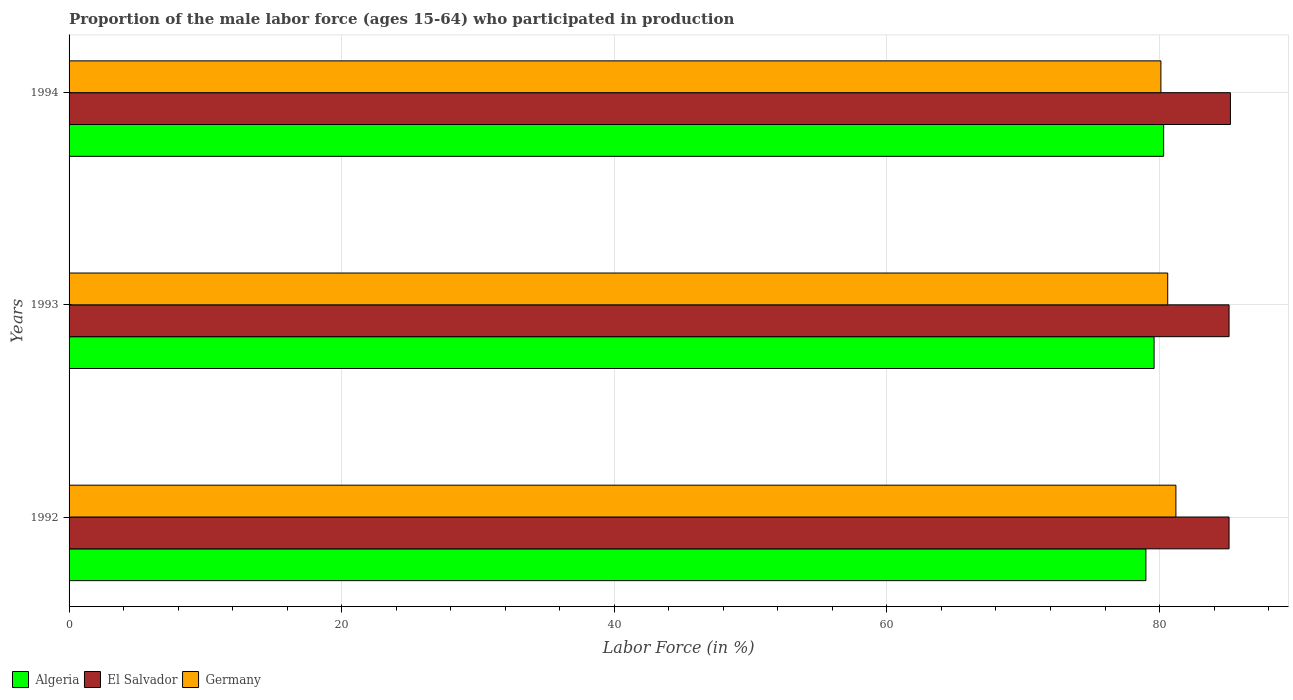How many different coloured bars are there?
Keep it short and to the point. 3. How many groups of bars are there?
Give a very brief answer. 3. Are the number of bars per tick equal to the number of legend labels?
Give a very brief answer. Yes. Are the number of bars on each tick of the Y-axis equal?
Provide a short and direct response. Yes. How many bars are there on the 3rd tick from the top?
Make the answer very short. 3. How many bars are there on the 3rd tick from the bottom?
Your answer should be compact. 3. In how many cases, is the number of bars for a given year not equal to the number of legend labels?
Your response must be concise. 0. What is the proportion of the male labor force who participated in production in El Salvador in 1994?
Your response must be concise. 85.2. Across all years, what is the maximum proportion of the male labor force who participated in production in Algeria?
Offer a terse response. 80.3. Across all years, what is the minimum proportion of the male labor force who participated in production in Algeria?
Keep it short and to the point. 79. What is the total proportion of the male labor force who participated in production in Algeria in the graph?
Your answer should be very brief. 238.9. What is the difference between the proportion of the male labor force who participated in production in Algeria in 1992 and that in 1994?
Ensure brevity in your answer.  -1.3. What is the difference between the proportion of the male labor force who participated in production in El Salvador in 1992 and the proportion of the male labor force who participated in production in Algeria in 1994?
Provide a short and direct response. 4.8. What is the average proportion of the male labor force who participated in production in Germany per year?
Keep it short and to the point. 80.63. In the year 1994, what is the difference between the proportion of the male labor force who participated in production in Algeria and proportion of the male labor force who participated in production in El Salvador?
Offer a terse response. -4.9. What is the ratio of the proportion of the male labor force who participated in production in Algeria in 1993 to that in 1994?
Offer a very short reply. 0.99. Is the proportion of the male labor force who participated in production in Germany in 1992 less than that in 1994?
Keep it short and to the point. No. Is the difference between the proportion of the male labor force who participated in production in Algeria in 1992 and 1993 greater than the difference between the proportion of the male labor force who participated in production in El Salvador in 1992 and 1993?
Give a very brief answer. No. What is the difference between the highest and the second highest proportion of the male labor force who participated in production in Algeria?
Offer a very short reply. 0.7. What is the difference between the highest and the lowest proportion of the male labor force who participated in production in Germany?
Ensure brevity in your answer.  1.1. In how many years, is the proportion of the male labor force who participated in production in Algeria greater than the average proportion of the male labor force who participated in production in Algeria taken over all years?
Offer a very short reply. 1. Is the sum of the proportion of the male labor force who participated in production in Algeria in 1992 and 1994 greater than the maximum proportion of the male labor force who participated in production in El Salvador across all years?
Keep it short and to the point. Yes. What does the 1st bar from the top in 1993 represents?
Your answer should be very brief. Germany. What does the 1st bar from the bottom in 1993 represents?
Make the answer very short. Algeria. Is it the case that in every year, the sum of the proportion of the male labor force who participated in production in Germany and proportion of the male labor force who participated in production in El Salvador is greater than the proportion of the male labor force who participated in production in Algeria?
Offer a terse response. Yes. How many bars are there?
Provide a succinct answer. 9. What is the difference between two consecutive major ticks on the X-axis?
Provide a succinct answer. 20. Are the values on the major ticks of X-axis written in scientific E-notation?
Your response must be concise. No. Does the graph contain any zero values?
Give a very brief answer. No. Does the graph contain grids?
Offer a very short reply. Yes. Where does the legend appear in the graph?
Your answer should be compact. Bottom left. How many legend labels are there?
Give a very brief answer. 3. What is the title of the graph?
Provide a succinct answer. Proportion of the male labor force (ages 15-64) who participated in production. Does "Hungary" appear as one of the legend labels in the graph?
Provide a succinct answer. No. What is the Labor Force (in %) in Algeria in 1992?
Provide a short and direct response. 79. What is the Labor Force (in %) of El Salvador in 1992?
Provide a short and direct response. 85.1. What is the Labor Force (in %) of Germany in 1992?
Your answer should be compact. 81.2. What is the Labor Force (in %) of Algeria in 1993?
Give a very brief answer. 79.6. What is the Labor Force (in %) in El Salvador in 1993?
Keep it short and to the point. 85.1. What is the Labor Force (in %) in Germany in 1993?
Provide a short and direct response. 80.6. What is the Labor Force (in %) in Algeria in 1994?
Give a very brief answer. 80.3. What is the Labor Force (in %) of El Salvador in 1994?
Offer a very short reply. 85.2. What is the Labor Force (in %) in Germany in 1994?
Your answer should be very brief. 80.1. Across all years, what is the maximum Labor Force (in %) in Algeria?
Provide a succinct answer. 80.3. Across all years, what is the maximum Labor Force (in %) of El Salvador?
Keep it short and to the point. 85.2. Across all years, what is the maximum Labor Force (in %) in Germany?
Your answer should be very brief. 81.2. Across all years, what is the minimum Labor Force (in %) of Algeria?
Offer a terse response. 79. Across all years, what is the minimum Labor Force (in %) in El Salvador?
Keep it short and to the point. 85.1. Across all years, what is the minimum Labor Force (in %) of Germany?
Your response must be concise. 80.1. What is the total Labor Force (in %) of Algeria in the graph?
Ensure brevity in your answer.  238.9. What is the total Labor Force (in %) in El Salvador in the graph?
Your answer should be compact. 255.4. What is the total Labor Force (in %) in Germany in the graph?
Make the answer very short. 241.9. What is the difference between the Labor Force (in %) of Germany in 1992 and that in 1994?
Your answer should be compact. 1.1. What is the difference between the Labor Force (in %) of Algeria in 1992 and the Labor Force (in %) of El Salvador in 1993?
Your response must be concise. -6.1. What is the difference between the Labor Force (in %) of El Salvador in 1992 and the Labor Force (in %) of Germany in 1993?
Ensure brevity in your answer.  4.5. What is the difference between the Labor Force (in %) in Algeria in 1992 and the Labor Force (in %) in Germany in 1994?
Provide a short and direct response. -1.1. What is the difference between the Labor Force (in %) in Algeria in 1993 and the Labor Force (in %) in El Salvador in 1994?
Make the answer very short. -5.6. What is the difference between the Labor Force (in %) in Algeria in 1993 and the Labor Force (in %) in Germany in 1994?
Your response must be concise. -0.5. What is the difference between the Labor Force (in %) in El Salvador in 1993 and the Labor Force (in %) in Germany in 1994?
Your response must be concise. 5. What is the average Labor Force (in %) of Algeria per year?
Your answer should be very brief. 79.63. What is the average Labor Force (in %) of El Salvador per year?
Provide a short and direct response. 85.13. What is the average Labor Force (in %) in Germany per year?
Make the answer very short. 80.63. In the year 1992, what is the difference between the Labor Force (in %) in Algeria and Labor Force (in %) in El Salvador?
Ensure brevity in your answer.  -6.1. In the year 1992, what is the difference between the Labor Force (in %) of El Salvador and Labor Force (in %) of Germany?
Provide a short and direct response. 3.9. In the year 1993, what is the difference between the Labor Force (in %) of El Salvador and Labor Force (in %) of Germany?
Your answer should be compact. 4.5. In the year 1994, what is the difference between the Labor Force (in %) of Algeria and Labor Force (in %) of El Salvador?
Provide a succinct answer. -4.9. In the year 1994, what is the difference between the Labor Force (in %) of El Salvador and Labor Force (in %) of Germany?
Keep it short and to the point. 5.1. What is the ratio of the Labor Force (in %) of Germany in 1992 to that in 1993?
Your response must be concise. 1.01. What is the ratio of the Labor Force (in %) in Algeria in 1992 to that in 1994?
Your response must be concise. 0.98. What is the ratio of the Labor Force (in %) of Germany in 1992 to that in 1994?
Your answer should be compact. 1.01. What is the ratio of the Labor Force (in %) of El Salvador in 1993 to that in 1994?
Your answer should be very brief. 1. What is the ratio of the Labor Force (in %) in Germany in 1993 to that in 1994?
Make the answer very short. 1.01. What is the difference between the highest and the second highest Labor Force (in %) of El Salvador?
Ensure brevity in your answer.  0.1. What is the difference between the highest and the lowest Labor Force (in %) of Algeria?
Offer a very short reply. 1.3. 